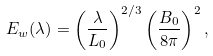Convert formula to latex. <formula><loc_0><loc_0><loc_500><loc_500>E _ { w } ( \lambda ) = \left ( \frac { \lambda } { L _ { 0 } } \right ) ^ { 2 / 3 } \left ( \frac { B _ { 0 } } { 8 \pi } \right ) ^ { 2 } ,</formula> 